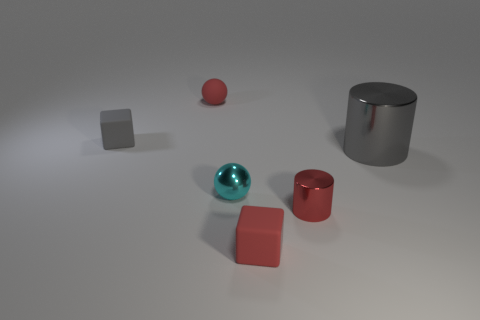Is the color of the large metallic cylinder the same as the cube that is in front of the cyan ball?
Your answer should be compact. No. What is the size of the gray thing that is the same material as the cyan ball?
Make the answer very short. Large. Are there any large matte balls that have the same color as the shiny ball?
Make the answer very short. No. How many things are either small red objects behind the tiny metal cylinder or small rubber balls?
Your answer should be very brief. 1. Are the big gray cylinder and the gray thing left of the tiny red cylinder made of the same material?
Provide a short and direct response. No. There is a cube that is the same color as the tiny metallic cylinder; what size is it?
Your answer should be compact. Small. Is there another small cyan sphere that has the same material as the cyan ball?
Give a very brief answer. No. What number of things are metallic cylinders that are to the left of the gray shiny thing or red spheres to the right of the tiny gray cube?
Ensure brevity in your answer.  2. There is a big metal object; is its shape the same as the shiny object that is in front of the small cyan metal sphere?
Give a very brief answer. Yes. What number of other objects are there of the same shape as the small gray object?
Provide a succinct answer. 1. 